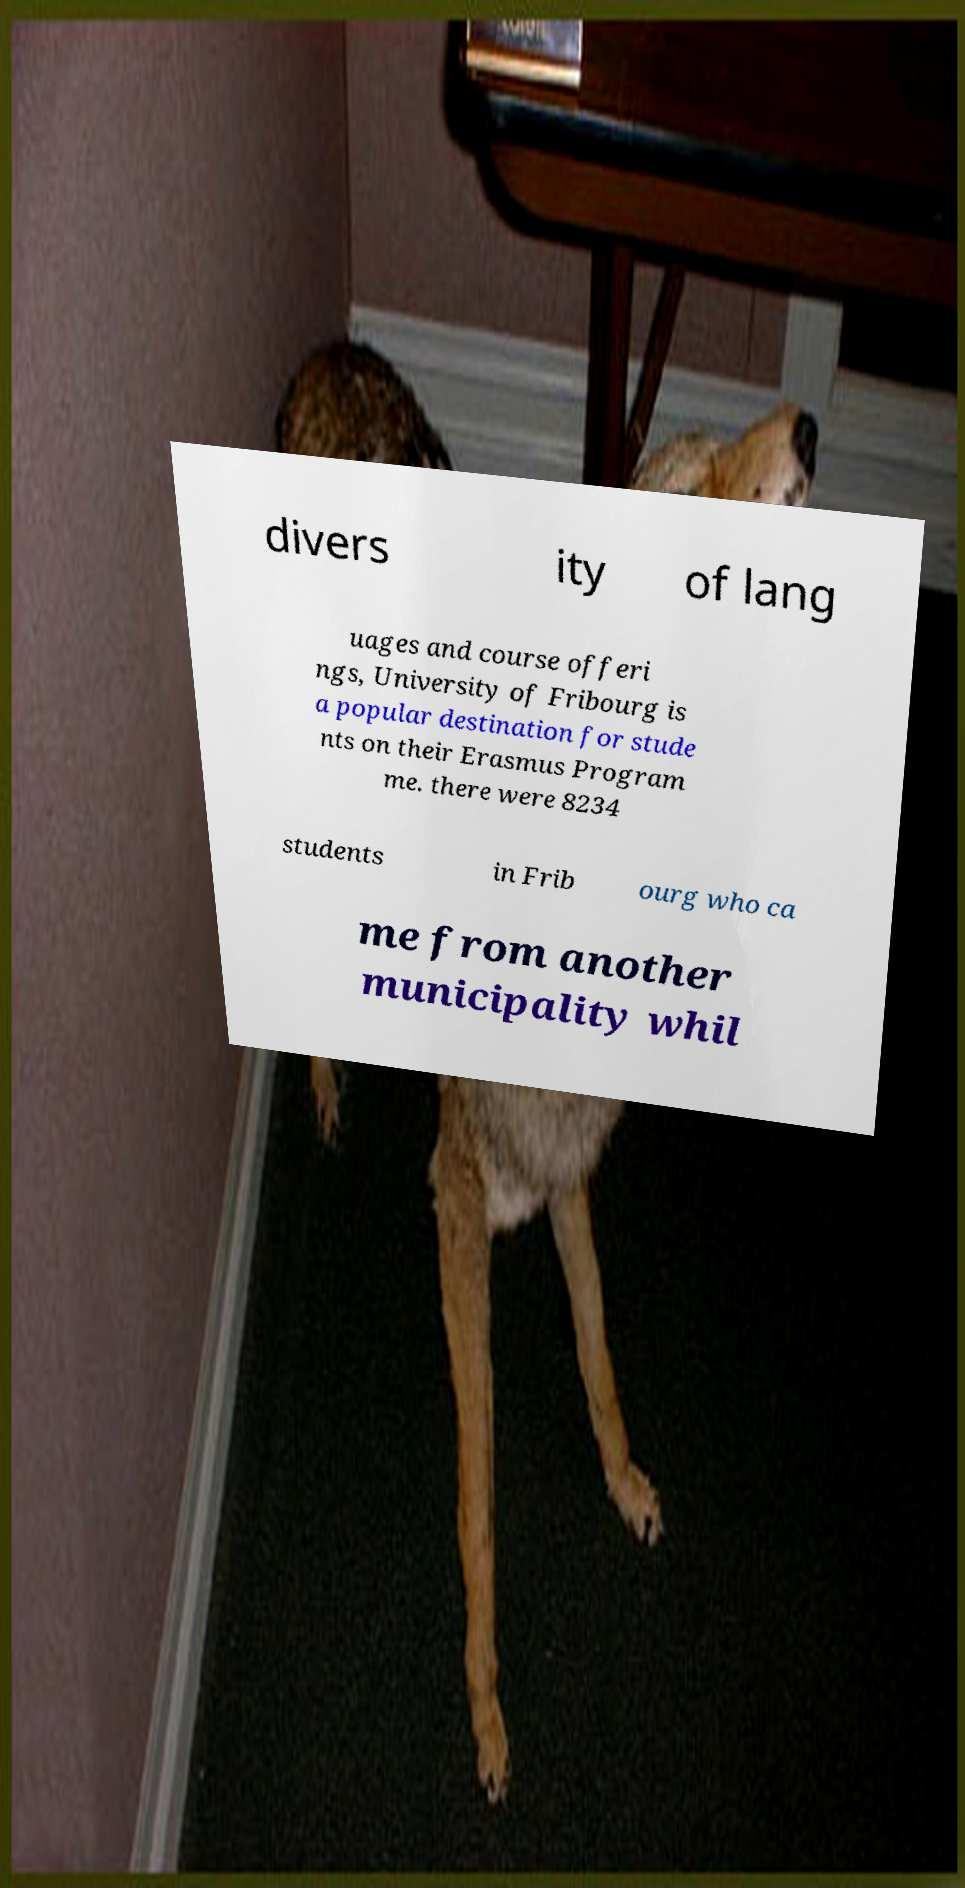Can you read and provide the text displayed in the image?This photo seems to have some interesting text. Can you extract and type it out for me? divers ity of lang uages and course offeri ngs, University of Fribourg is a popular destination for stude nts on their Erasmus Program me. there were 8234 students in Frib ourg who ca me from another municipality whil 